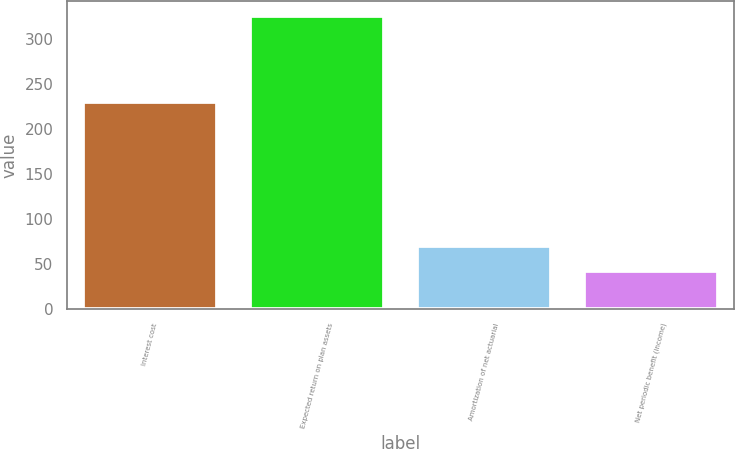<chart> <loc_0><loc_0><loc_500><loc_500><bar_chart><fcel>Interest cost<fcel>Expected return on plan assets<fcel>Amortization of net actuarial<fcel>Net periodic benefit (income)<nl><fcel>230<fcel>326<fcel>70.4<fcel>42<nl></chart> 